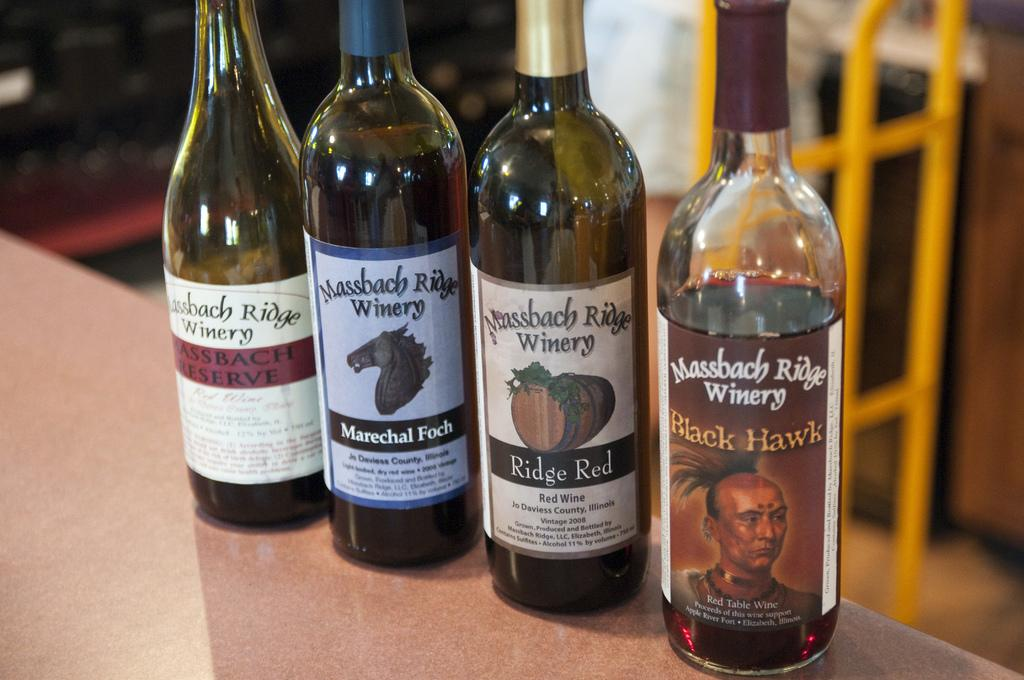<image>
Render a clear and concise summary of the photo. Four bottles of wine from Massbach Ridge winery are on a table. 